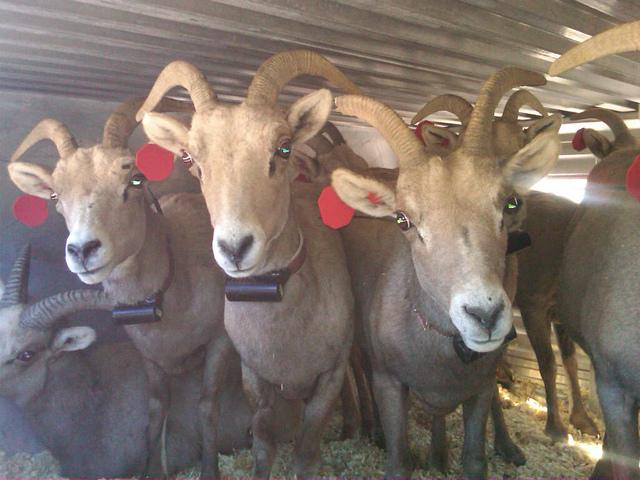What type of loose material is strewn on the floor where the animals are standing? hay 